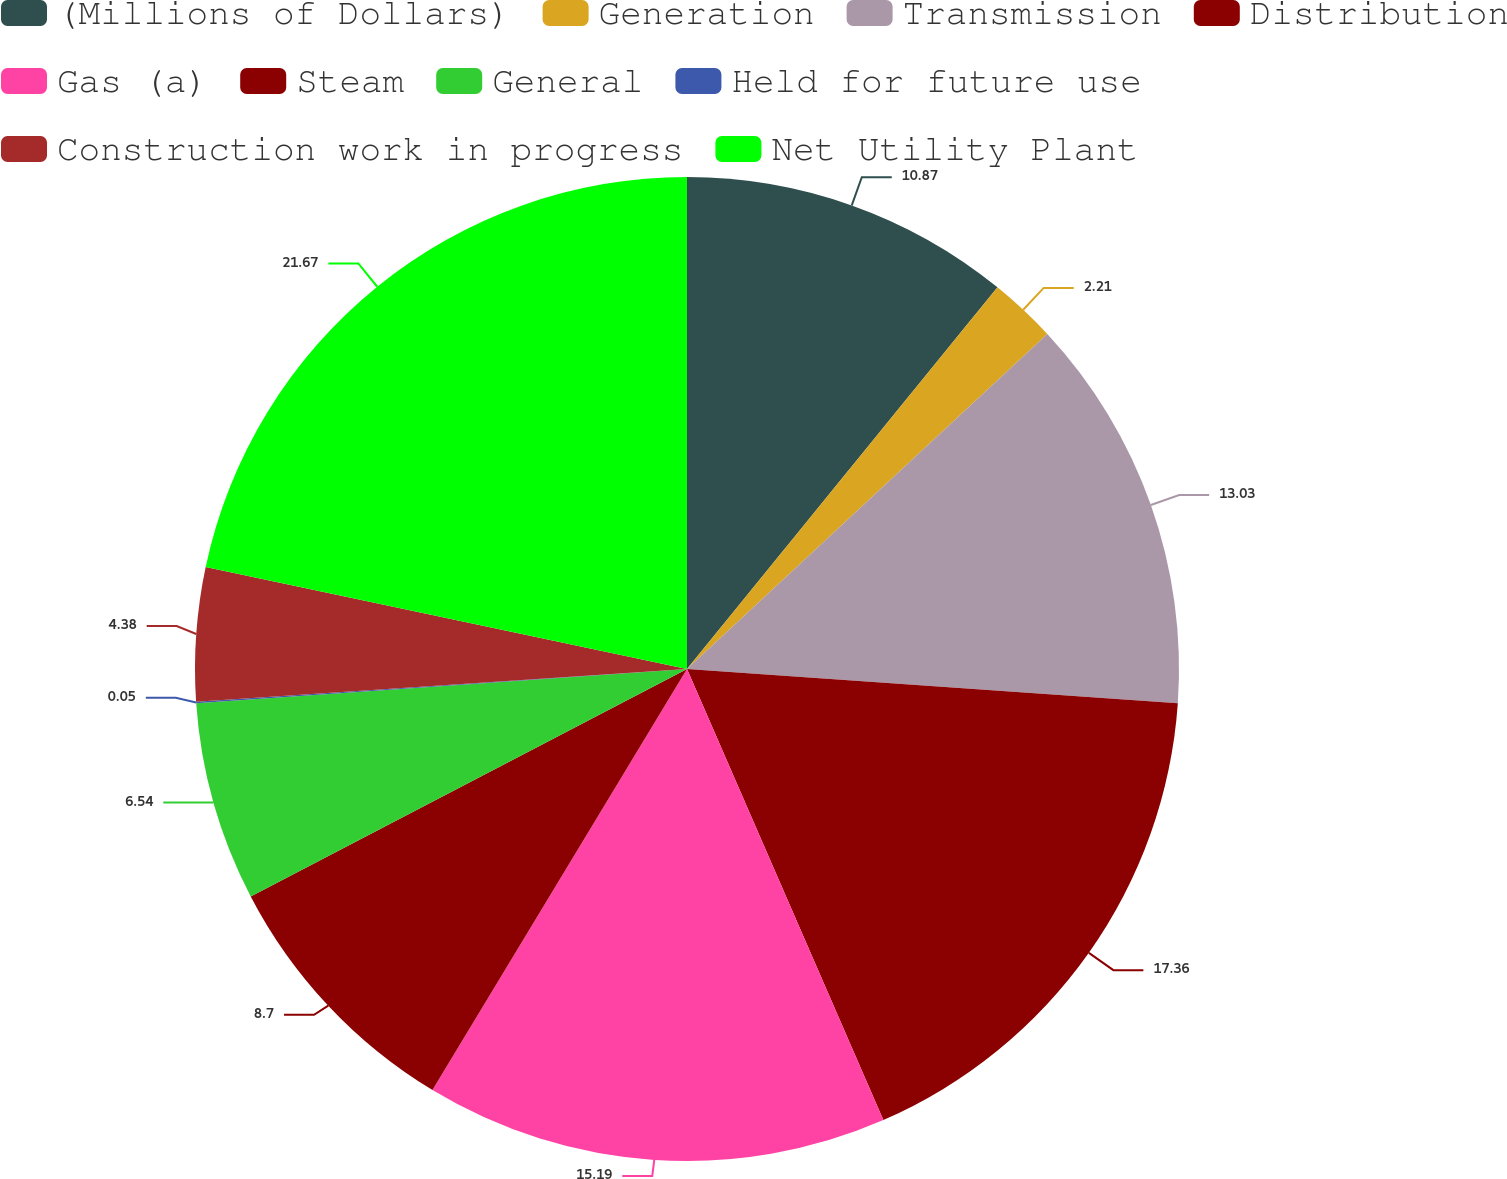<chart> <loc_0><loc_0><loc_500><loc_500><pie_chart><fcel>(Millions of Dollars)<fcel>Generation<fcel>Transmission<fcel>Distribution<fcel>Gas (a)<fcel>Steam<fcel>General<fcel>Held for future use<fcel>Construction work in progress<fcel>Net Utility Plant<nl><fcel>10.87%<fcel>2.21%<fcel>13.03%<fcel>17.36%<fcel>15.19%<fcel>8.7%<fcel>6.54%<fcel>0.05%<fcel>4.38%<fcel>21.68%<nl></chart> 